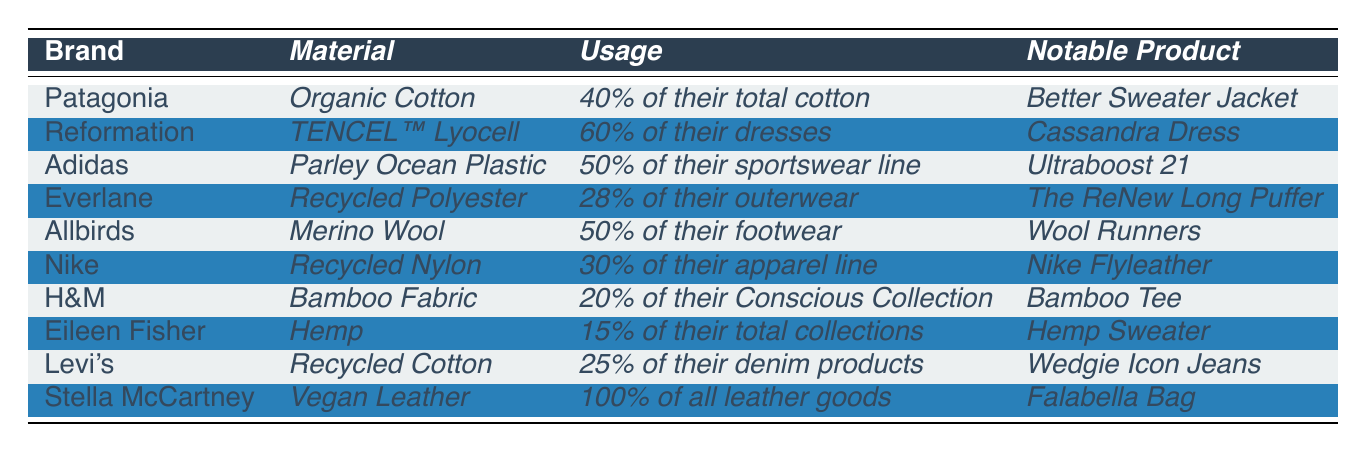What sustainable material does Patagonia use the most? According to the table, Patagonia uses _Organic Cotton_, which is _40%_ of their total cotton.
Answer: Organic Cotton Which brand uses _TENCEL™ Lyocell_ for more than half of its dresses? The table indicates that _Reformation_ utilizes _TENCEL™ Lyocell_ in _60%_ of their dresses.
Answer: Reformation What is the notable product of Adidas? From the table, the notable product for Adidas is the _Ultraboost 21_.
Answer: Ultraboost 21 Which brand has the highest percentage of usage for its sustainable material? Looking at the table, _Stella McCartney_ has _100%_ usage of _Vegan Leather_ for all its leather goods, which is the highest.
Answer: Stella McCartney If you combined the usage percentages of the materials used by Everlane and Nike, what would that total be? Everlane uses _28%_ of _Recycled Polyester_ and Nike uses _30%_ of _Recycled Nylon_. When added together, _28 + 30 = 58%_.
Answer: 58% Is H&M’s usage of sustainable materials above or below 25%? The table shows H&M's usage of _Bamboo Fabric_ is _20%_ of their Conscious Collection, which is below 25%.
Answer: Below What percentage of Levi's denim products is made of _Recycled Cotton_? The table states that _25%_ of Levi's denim products is made of _Recycled Cotton_.
Answer: 25% How many brands use materials that involve recycling? In the table, the brands using recycled materials are Everlane (_Recycled Polyester_), Nike (_Recycled Nylon_), Levi's (_Recycled Cotton_), and Adidas (_Parley Ocean Plastic_), making it a total of _4_ brands.
Answer: 4 Which brand has the lowest percentage of usage for their sustainable materials? Comparing the percentages, _Eileen Fisher_ has the lowest at _15%_ for _Hemp_.
Answer: Eileen Fisher If a new brand were to add a product that combines Recycled Polyester and Vegan Leather, what trends would they follow based on this table? They would follow trends for using recycled materials and avoiding animal-derived products, as shown by Everlane and Stella McCartney’s sustainable materials.
Answer: Recycled materials and vegan products What is the notable product of Allbirds? According to the table, Allbirds' notable product is the _Wool Runners_.
Answer: Wool Runners 